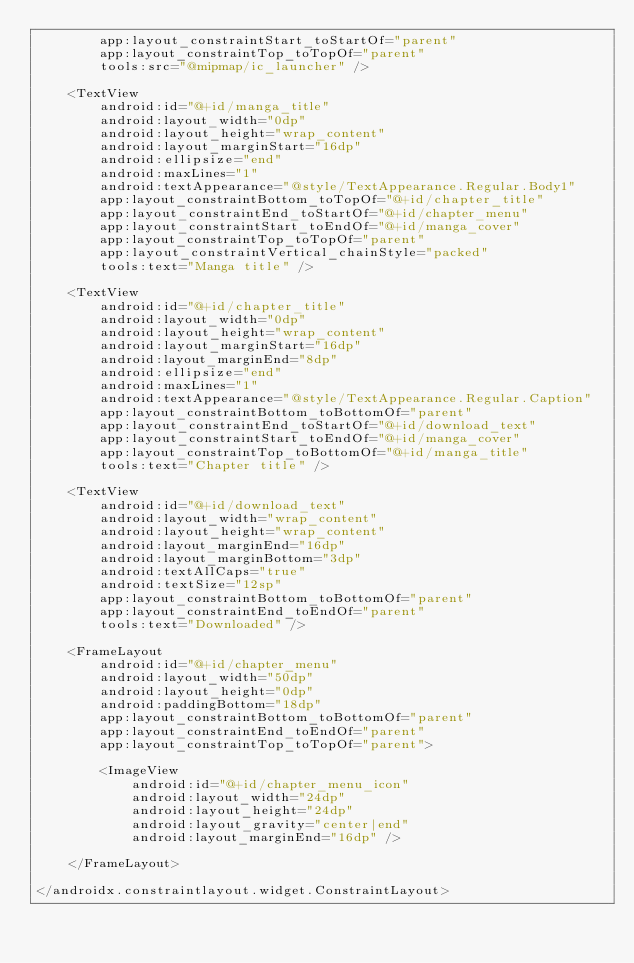<code> <loc_0><loc_0><loc_500><loc_500><_XML_>        app:layout_constraintStart_toStartOf="parent"
        app:layout_constraintTop_toTopOf="parent"
        tools:src="@mipmap/ic_launcher" />

    <TextView
        android:id="@+id/manga_title"
        android:layout_width="0dp"
        android:layout_height="wrap_content"
        android:layout_marginStart="16dp"
        android:ellipsize="end"
        android:maxLines="1"
        android:textAppearance="@style/TextAppearance.Regular.Body1"
        app:layout_constraintBottom_toTopOf="@+id/chapter_title"
        app:layout_constraintEnd_toStartOf="@+id/chapter_menu"
        app:layout_constraintStart_toEndOf="@+id/manga_cover"
        app:layout_constraintTop_toTopOf="parent"
        app:layout_constraintVertical_chainStyle="packed"
        tools:text="Manga title" />

    <TextView
        android:id="@+id/chapter_title"
        android:layout_width="0dp"
        android:layout_height="wrap_content"
        android:layout_marginStart="16dp"
        android:layout_marginEnd="8dp"
        android:ellipsize="end"
        android:maxLines="1"
        android:textAppearance="@style/TextAppearance.Regular.Caption"
        app:layout_constraintBottom_toBottomOf="parent"
        app:layout_constraintEnd_toStartOf="@+id/download_text"
        app:layout_constraintStart_toEndOf="@+id/manga_cover"
        app:layout_constraintTop_toBottomOf="@+id/manga_title"
        tools:text="Chapter title" />

    <TextView
        android:id="@+id/download_text"
        android:layout_width="wrap_content"
        android:layout_height="wrap_content"
        android:layout_marginEnd="16dp"
        android:layout_marginBottom="3dp"
        android:textAllCaps="true"
        android:textSize="12sp"
        app:layout_constraintBottom_toBottomOf="parent"
        app:layout_constraintEnd_toEndOf="parent"
        tools:text="Downloaded" />

    <FrameLayout
        android:id="@+id/chapter_menu"
        android:layout_width="50dp"
        android:layout_height="0dp"
        android:paddingBottom="18dp"
        app:layout_constraintBottom_toBottomOf="parent"
        app:layout_constraintEnd_toEndOf="parent"
        app:layout_constraintTop_toTopOf="parent">

        <ImageView
            android:id="@+id/chapter_menu_icon"
            android:layout_width="24dp"
            android:layout_height="24dp"
            android:layout_gravity="center|end"
            android:layout_marginEnd="16dp" />

    </FrameLayout>

</androidx.constraintlayout.widget.ConstraintLayout>
</code> 